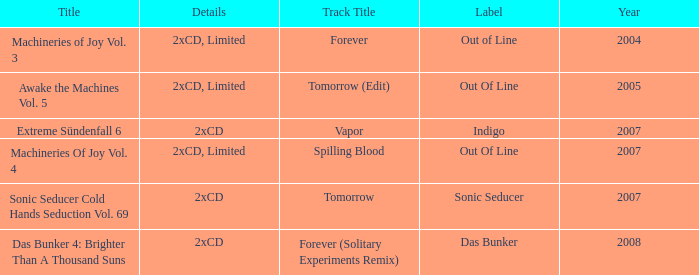Which details has the out of line label and the year of 2005? 2xCD, Limited. 